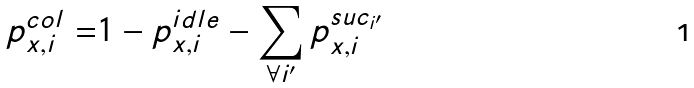<formula> <loc_0><loc_0><loc_500><loc_500>p _ { x , i } ^ { c o l } = & 1 - p _ { x , i } ^ { i d l e } - \sum _ { \forall i ^ { \prime } } p _ { x , i } ^ { s u c _ { i ^ { \prime } } }</formula> 